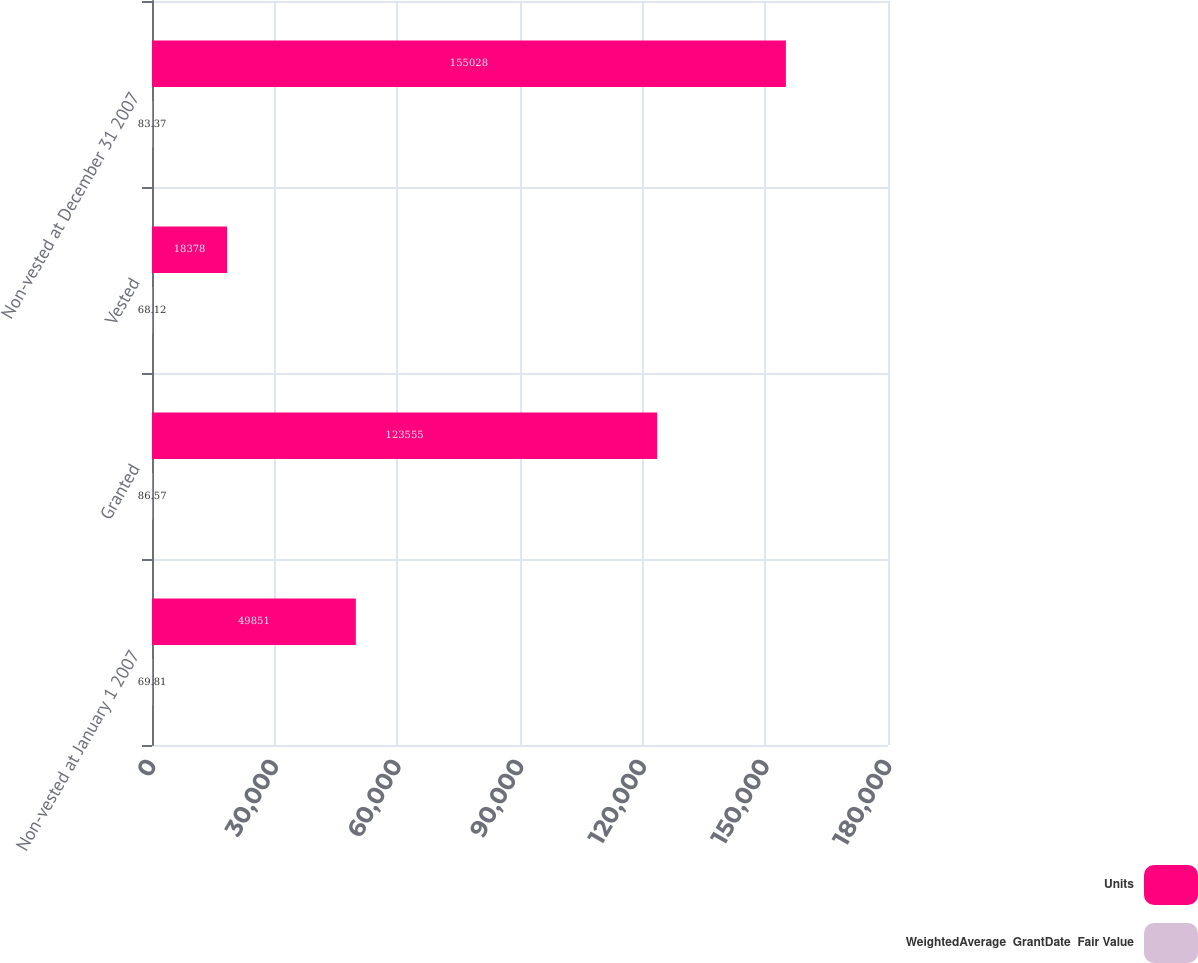<chart> <loc_0><loc_0><loc_500><loc_500><stacked_bar_chart><ecel><fcel>Non-vested at January 1 2007<fcel>Granted<fcel>Vested<fcel>Non-vested at December 31 2007<nl><fcel>Units<fcel>49851<fcel>123555<fcel>18378<fcel>155028<nl><fcel>WeightedAverage  GrantDate  Fair Value<fcel>69.81<fcel>86.57<fcel>68.12<fcel>83.37<nl></chart> 